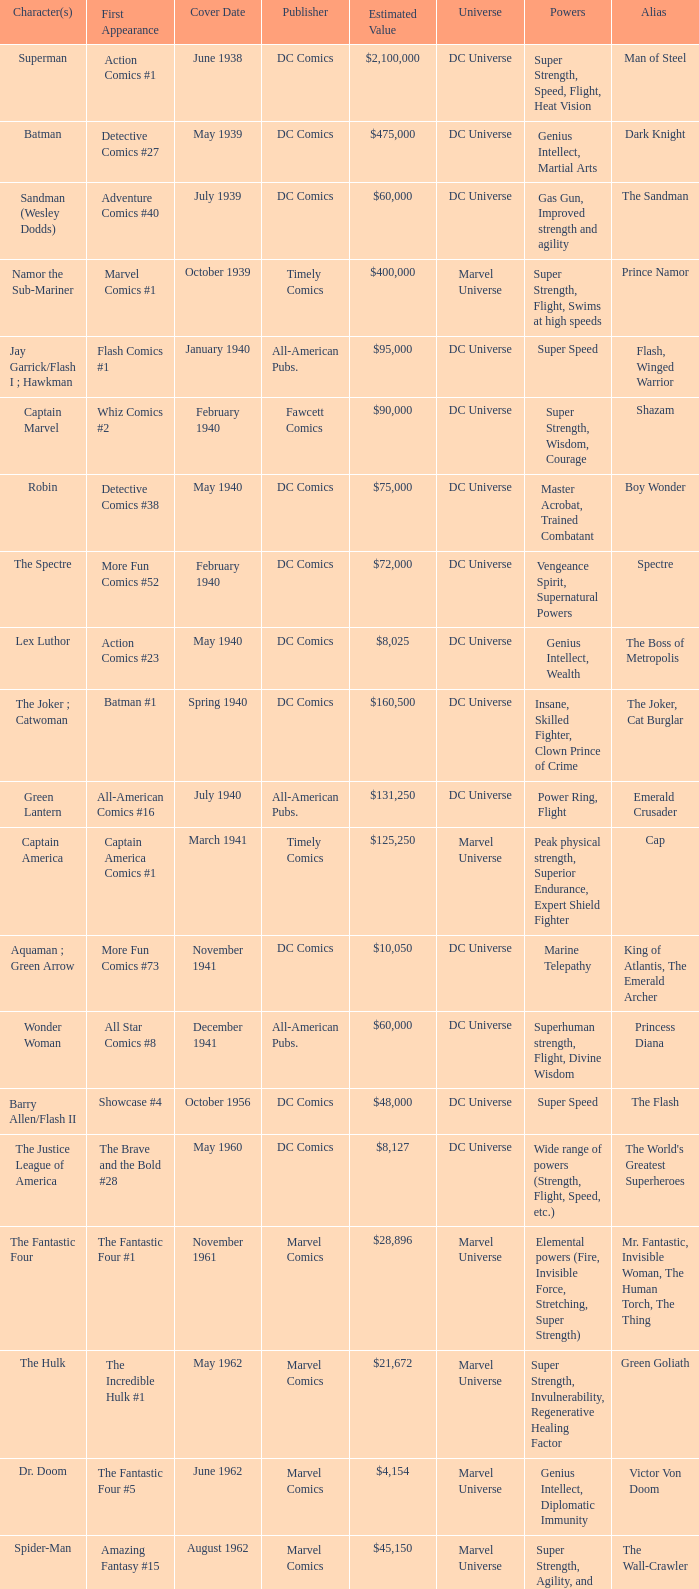Which character first appeared in Amazing Fantasy #15? Spider-Man. 